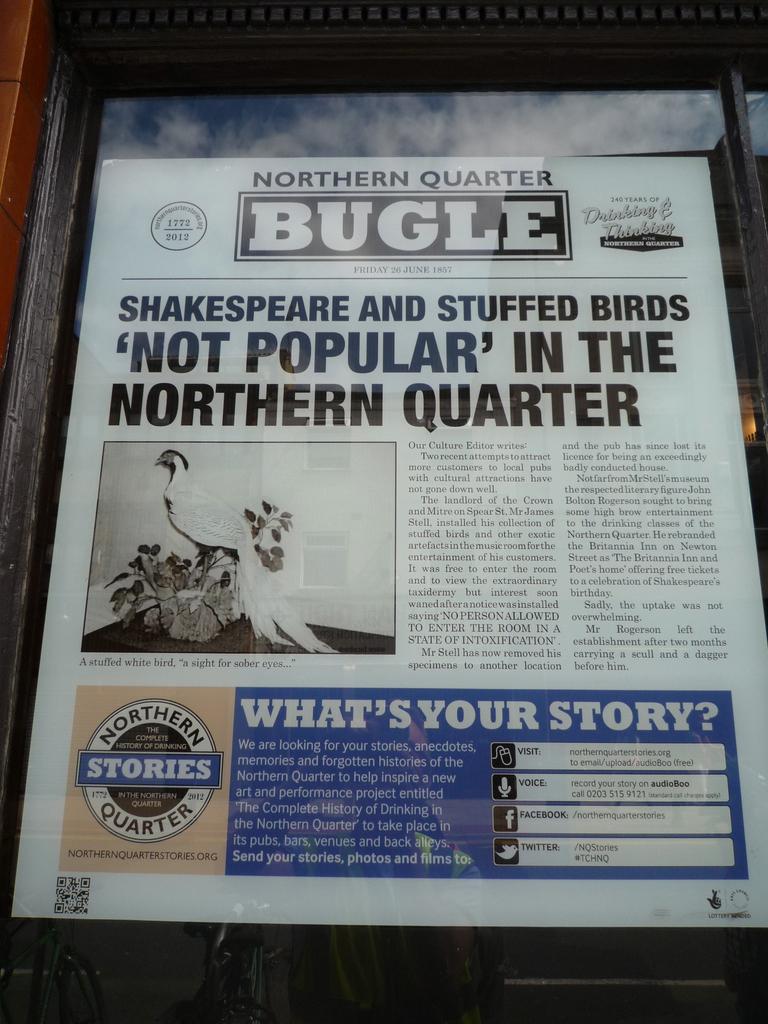What is the name of this paper?
Keep it short and to the point. Northern quarter bugle. What is the title in the blue box?
Your answer should be very brief. What's your story. 